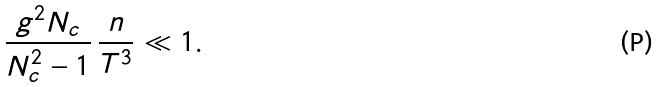<formula> <loc_0><loc_0><loc_500><loc_500>\frac { g ^ { 2 } N _ { c } } { N _ { c } ^ { 2 } - 1 } \, \frac { n } { T ^ { 3 } } \ll 1 .</formula> 